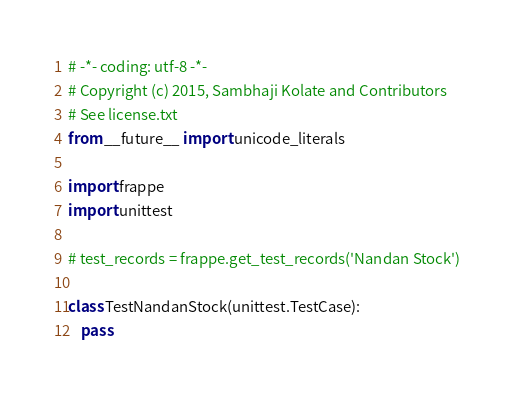Convert code to text. <code><loc_0><loc_0><loc_500><loc_500><_Python_># -*- coding: utf-8 -*-
# Copyright (c) 2015, Sambhaji Kolate and Contributors
# See license.txt
from __future__ import unicode_literals

import frappe
import unittest

# test_records = frappe.get_test_records('Nandan Stock')

class TestNandanStock(unittest.TestCase):
	pass
</code> 